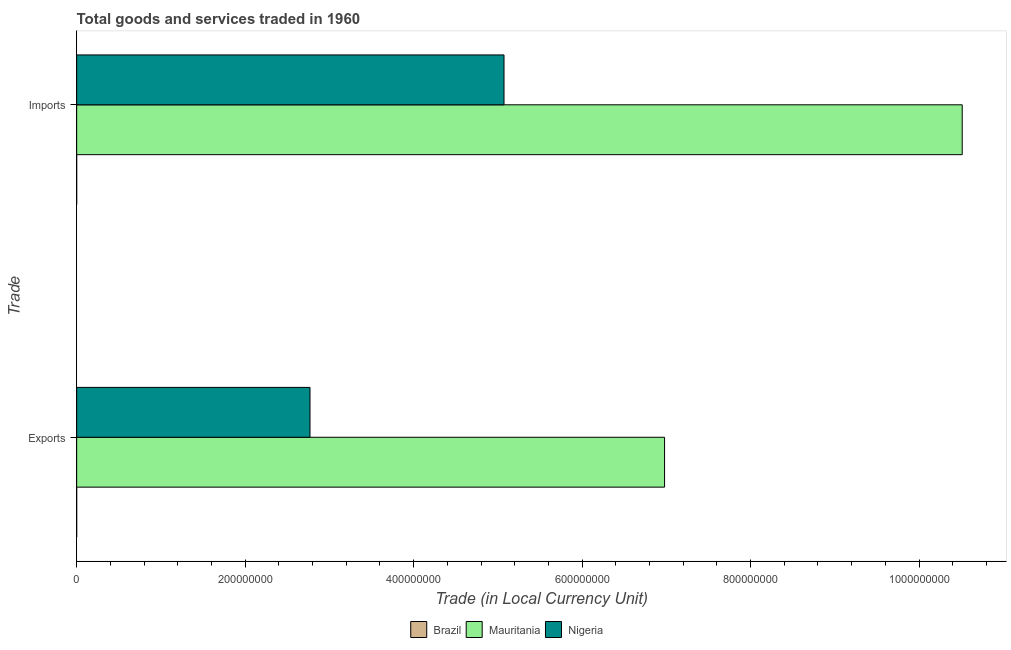How many different coloured bars are there?
Provide a succinct answer. 3. Are the number of bars per tick equal to the number of legend labels?
Provide a succinct answer. Yes. How many bars are there on the 2nd tick from the bottom?
Your response must be concise. 3. What is the label of the 2nd group of bars from the top?
Offer a terse response. Exports. What is the export of goods and services in Nigeria?
Your answer should be very brief. 2.77e+08. Across all countries, what is the maximum imports of goods and services?
Your answer should be compact. 1.05e+09. Across all countries, what is the minimum export of goods and services?
Keep it short and to the point. 7.27491e-5. In which country was the export of goods and services maximum?
Give a very brief answer. Mauritania. What is the total export of goods and services in the graph?
Your response must be concise. 9.75e+08. What is the difference between the imports of goods and services in Brazil and that in Nigeria?
Offer a very short reply. -5.07e+08. What is the difference between the imports of goods and services in Brazil and the export of goods and services in Nigeria?
Your response must be concise. -2.77e+08. What is the average imports of goods and services per country?
Your answer should be compact. 5.19e+08. What is the difference between the export of goods and services and imports of goods and services in Brazil?
Ensure brevity in your answer.  -6.002000000000015e-7. In how many countries, is the export of goods and services greater than 280000000 LCU?
Provide a succinct answer. 1. What is the ratio of the export of goods and services in Mauritania to that in Brazil?
Your answer should be compact. 9.59e+12. In how many countries, is the imports of goods and services greater than the average imports of goods and services taken over all countries?
Your answer should be very brief. 1. What does the 1st bar from the top in Imports represents?
Offer a terse response. Nigeria. What does the 2nd bar from the bottom in Exports represents?
Make the answer very short. Mauritania. How many bars are there?
Your answer should be very brief. 6. Are the values on the major ticks of X-axis written in scientific E-notation?
Your response must be concise. No. Does the graph contain any zero values?
Ensure brevity in your answer.  No. Does the graph contain grids?
Your answer should be very brief. No. How are the legend labels stacked?
Give a very brief answer. Horizontal. What is the title of the graph?
Keep it short and to the point. Total goods and services traded in 1960. Does "Tanzania" appear as one of the legend labels in the graph?
Make the answer very short. No. What is the label or title of the X-axis?
Your answer should be compact. Trade (in Local Currency Unit). What is the label or title of the Y-axis?
Make the answer very short. Trade. What is the Trade (in Local Currency Unit) of Brazil in Exports?
Ensure brevity in your answer.  7.27491e-5. What is the Trade (in Local Currency Unit) in Mauritania in Exports?
Make the answer very short. 6.98e+08. What is the Trade (in Local Currency Unit) of Nigeria in Exports?
Your answer should be very brief. 2.77e+08. What is the Trade (in Local Currency Unit) of Brazil in Imports?
Your answer should be very brief. 7.33493e-5. What is the Trade (in Local Currency Unit) of Mauritania in Imports?
Your answer should be compact. 1.05e+09. What is the Trade (in Local Currency Unit) in Nigeria in Imports?
Offer a terse response. 5.07e+08. Across all Trade, what is the maximum Trade (in Local Currency Unit) of Brazil?
Keep it short and to the point. 7.33493e-5. Across all Trade, what is the maximum Trade (in Local Currency Unit) in Mauritania?
Offer a terse response. 1.05e+09. Across all Trade, what is the maximum Trade (in Local Currency Unit) in Nigeria?
Ensure brevity in your answer.  5.07e+08. Across all Trade, what is the minimum Trade (in Local Currency Unit) of Brazil?
Provide a short and direct response. 7.27491e-5. Across all Trade, what is the minimum Trade (in Local Currency Unit) in Mauritania?
Keep it short and to the point. 6.98e+08. Across all Trade, what is the minimum Trade (in Local Currency Unit) in Nigeria?
Make the answer very short. 2.77e+08. What is the total Trade (in Local Currency Unit) in Mauritania in the graph?
Offer a terse response. 1.75e+09. What is the total Trade (in Local Currency Unit) in Nigeria in the graph?
Offer a terse response. 7.84e+08. What is the difference between the Trade (in Local Currency Unit) of Mauritania in Exports and that in Imports?
Offer a terse response. -3.53e+08. What is the difference between the Trade (in Local Currency Unit) of Nigeria in Exports and that in Imports?
Offer a terse response. -2.30e+08. What is the difference between the Trade (in Local Currency Unit) of Brazil in Exports and the Trade (in Local Currency Unit) of Mauritania in Imports?
Offer a terse response. -1.05e+09. What is the difference between the Trade (in Local Currency Unit) of Brazil in Exports and the Trade (in Local Currency Unit) of Nigeria in Imports?
Your answer should be very brief. -5.07e+08. What is the difference between the Trade (in Local Currency Unit) of Mauritania in Exports and the Trade (in Local Currency Unit) of Nigeria in Imports?
Your answer should be compact. 1.91e+08. What is the average Trade (in Local Currency Unit) of Mauritania per Trade?
Keep it short and to the point. 8.75e+08. What is the average Trade (in Local Currency Unit) of Nigeria per Trade?
Keep it short and to the point. 3.92e+08. What is the difference between the Trade (in Local Currency Unit) of Brazil and Trade (in Local Currency Unit) of Mauritania in Exports?
Make the answer very short. -6.98e+08. What is the difference between the Trade (in Local Currency Unit) in Brazil and Trade (in Local Currency Unit) in Nigeria in Exports?
Your response must be concise. -2.77e+08. What is the difference between the Trade (in Local Currency Unit) in Mauritania and Trade (in Local Currency Unit) in Nigeria in Exports?
Give a very brief answer. 4.21e+08. What is the difference between the Trade (in Local Currency Unit) in Brazil and Trade (in Local Currency Unit) in Mauritania in Imports?
Provide a succinct answer. -1.05e+09. What is the difference between the Trade (in Local Currency Unit) of Brazil and Trade (in Local Currency Unit) of Nigeria in Imports?
Offer a very short reply. -5.07e+08. What is the difference between the Trade (in Local Currency Unit) in Mauritania and Trade (in Local Currency Unit) in Nigeria in Imports?
Your response must be concise. 5.44e+08. What is the ratio of the Trade (in Local Currency Unit) of Mauritania in Exports to that in Imports?
Give a very brief answer. 0.66. What is the ratio of the Trade (in Local Currency Unit) in Nigeria in Exports to that in Imports?
Your answer should be very brief. 0.55. What is the difference between the highest and the second highest Trade (in Local Currency Unit) of Mauritania?
Offer a terse response. 3.53e+08. What is the difference between the highest and the second highest Trade (in Local Currency Unit) in Nigeria?
Your answer should be very brief. 2.30e+08. What is the difference between the highest and the lowest Trade (in Local Currency Unit) in Brazil?
Provide a succinct answer. 0. What is the difference between the highest and the lowest Trade (in Local Currency Unit) in Mauritania?
Keep it short and to the point. 3.53e+08. What is the difference between the highest and the lowest Trade (in Local Currency Unit) of Nigeria?
Your response must be concise. 2.30e+08. 